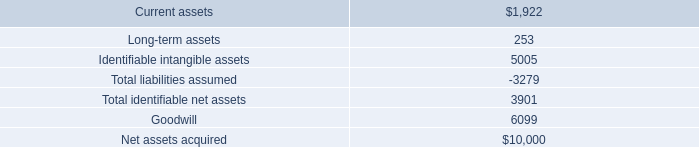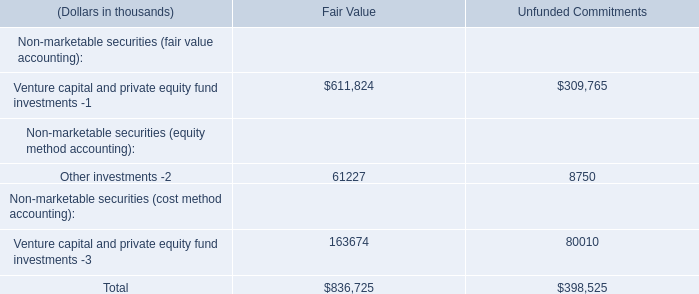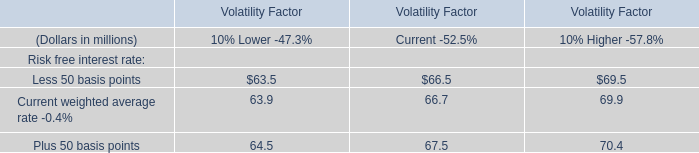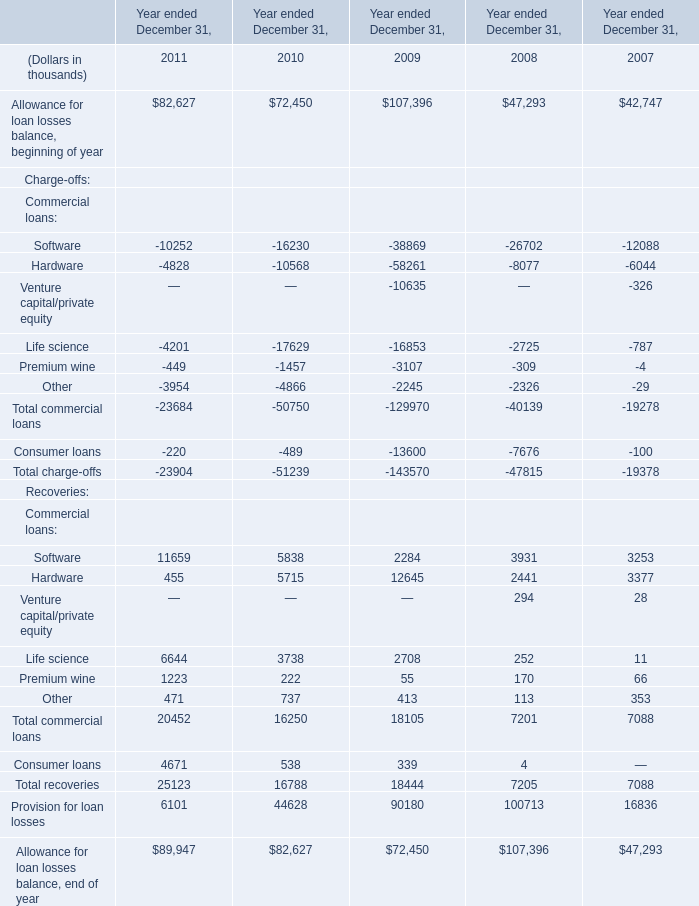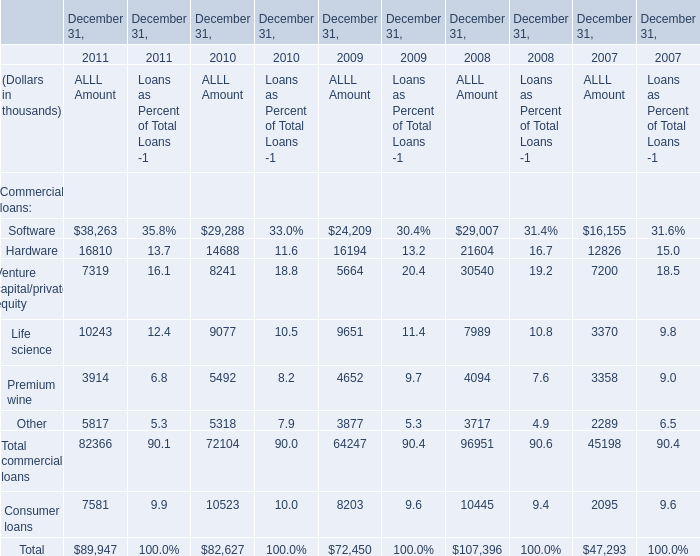What's the current growth rate of Hardware for ALLL Amount ? 
Computations: ((16810 - 14688) / 14688)
Answer: 0.14447. 